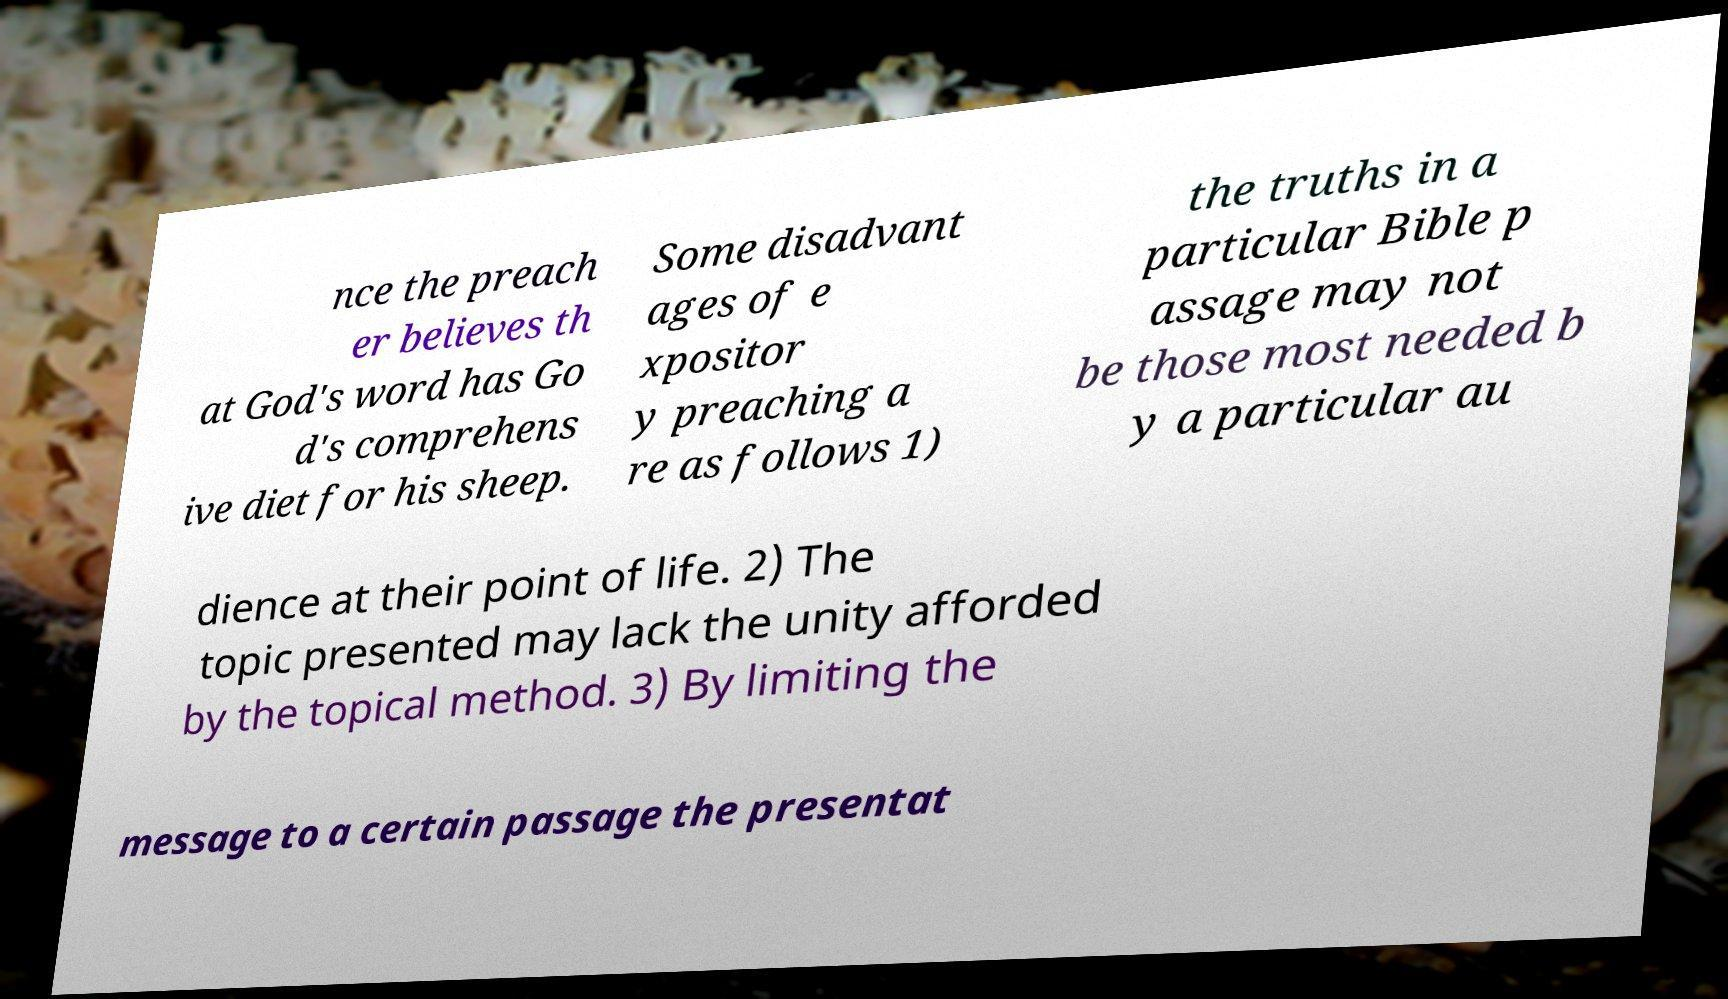What messages or text are displayed in this image? I need them in a readable, typed format. nce the preach er believes th at God's word has Go d's comprehens ive diet for his sheep. Some disadvant ages of e xpositor y preaching a re as follows 1) the truths in a particular Bible p assage may not be those most needed b y a particular au dience at their point of life. 2) The topic presented may lack the unity afforded by the topical method. 3) By limiting the message to a certain passage the presentat 